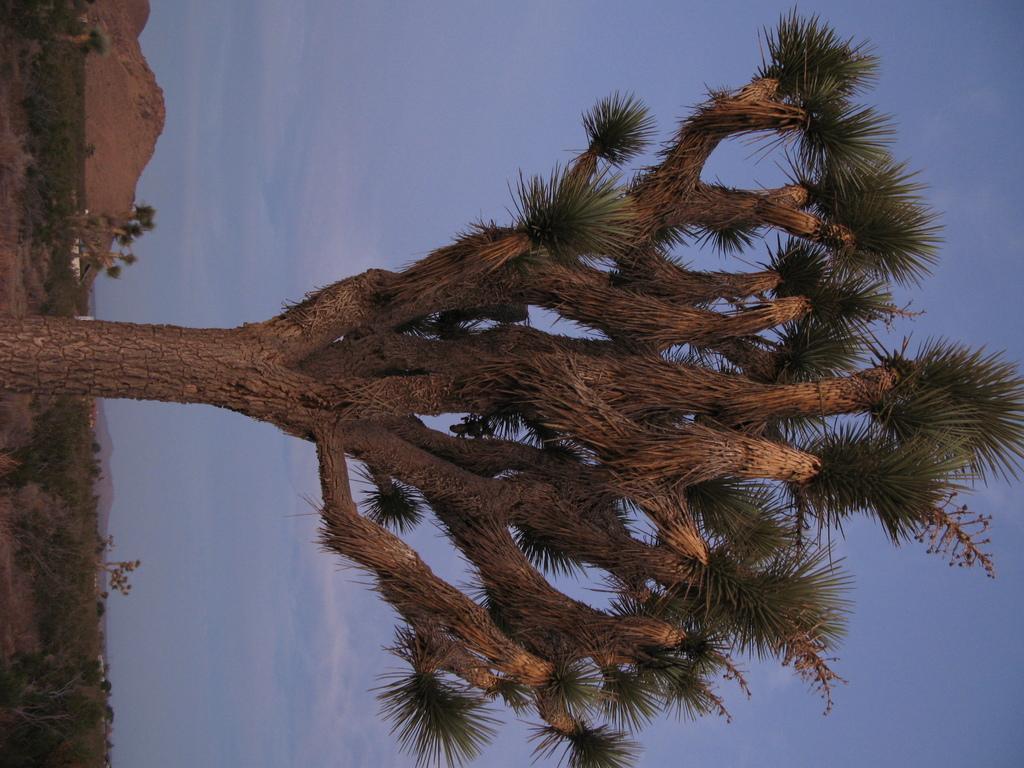In one or two sentences, can you explain what this image depicts? In this picture we can see some trees, plants and mountains, In the background, we can see the sky with clouds. 